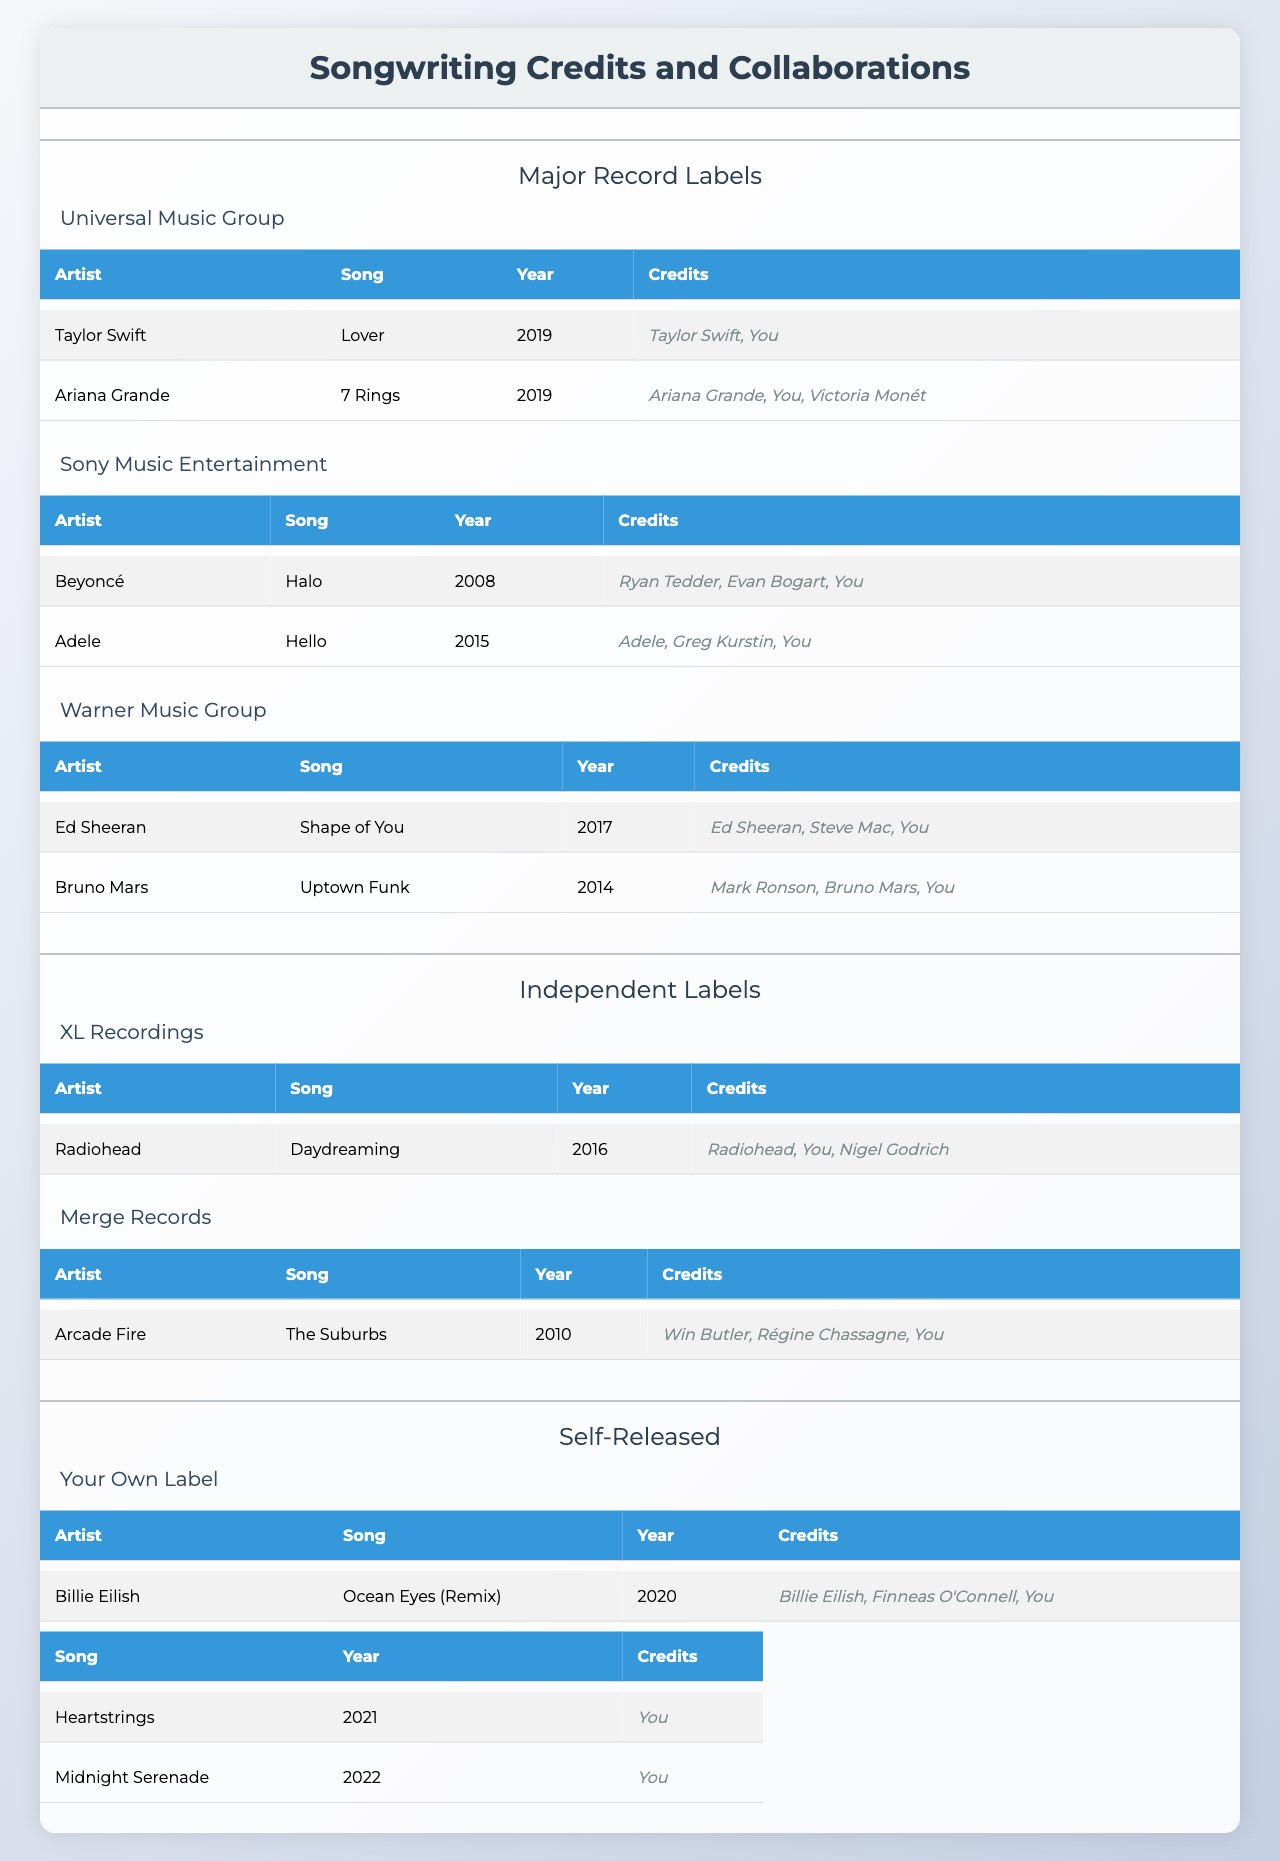What is the title of the song you collaborated on with Taylor Swift? The table indicates that the song you collaborated on with Taylor Swift is titled "Lover." This is found in the collaborations under Universal Music Group.
Answer: Lover How many songs did you collaborate on with artists from Sony Music Entertainment? There are two collaborations listed under Sony Music Entertainment: "Halo" with Beyoncé and "Hello" with Adele. Therefore, the total is 2 songs.
Answer: 2 Which song features Ed Sheeran as the collaborating artist? The table lists "Shape of You" as the song that features Ed Sheeran as the collaborating artist. This can be found under Warner Music Group.
Answer: Shape of You Did you collaborate on any songs with independent labels? Yes, the table shows a collaboration with Radiohead on the song "Daydreaming" under XL Recordings, indicating you did collaborate with an independent label.
Answer: Yes How many years apart were the collaborations with Ariana Grande and Adele? The collaboration with Ariana Grande on "7 Rings" was in 2019 and the collaboration with Adele on "Hello" was in 2015. The difference in years is 2019 - 2015 = 4 years.
Answer: 4 years Which record label had a collaboration involving Billie Eilish? The collaboration with Billie Eilish on "Ocean Eyes (Remix)" is listed under Your Own Label, which is categorized as self-released.
Answer: Your Own Label What percentage of your collaborations involve major record labels? You have 6 collaborations in total (2 from Universal, 2 from Sony, 2 from Warner) and 1 from Your Own Label. Therefore, 6 out of 7 collaborations are from major labels, which is approximately (6/7)*100 = 85.71%.
Answer: 85.71% Who are the credits for the song "The Suburbs"? The credits for "The Suburbs" as noted in the table are Win Butler, Régine Chassagne, and you. This information is available under Merge Records in Independent Labels.
Answer: Win Butler, Régine Chassagne, You Is "Midnight Serenade" a solo work or a collaboration? According to the table, "Midnight Serenade" is listed under Solo Works, confirming that it is a solo work.
Answer: Solo work Which artist did you collaborate with on a song released in 2020? The table shows that the collaboration in 2020 was with Billie Eilish on "Ocean Eyes (Remix)." This can be found in the self-released section.
Answer: Billie Eilish How many total collaborations did you have across all labels? The table lists a total of 6 collaborations: 2 from Universal, 2 from Sony, 2 from Warner, and 1 from your self-released label, giving a total of 7 collaborations overall.
Answer: 7 